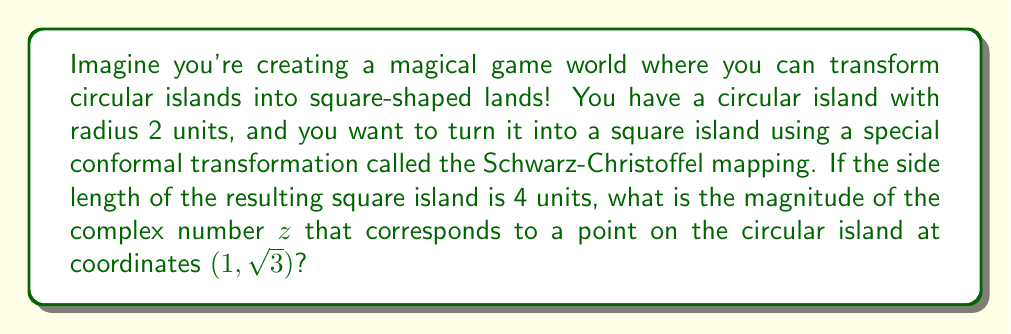Solve this math problem. Let's approach this step-by-step:

1) First, we need to understand that the Schwarz-Christoffel mapping can transform a circle into a square. This is a type of conformal mapping, which means it preserves angles.

2) The point (1, $\sqrt{3}$) on the circular island can be represented as a complex number:

   $z = 1 + i\sqrt{3}$

3) To find the magnitude of this complex number, we use the formula:

   $|z| = \sqrt{a^2 + b^2}$, where $z = a + bi$

4) In this case:

   $|z| = \sqrt{1^2 + (\sqrt{3})^2} = \sqrt{1 + 3} = \sqrt{4} = 2$

5) Now, we've confirmed that this point is indeed on the circle with radius 2.

6) The Schwarz-Christoffel mapping preserves the relative positions of points. This means that a point on the edge of the circle will map to a point on the edge of the square.

7) The circular island has a radius of 2, so its diameter is 4. The square island has a side length of 4. This means the mapping preserves the overall size of the shape.

8) Therefore, the point we're looking at will still be on the edge of the transformed shape, and its distance from the center (i.e., its magnitude) will remain unchanged.

So, the magnitude of the complex number $z$ remains 2, even after the transformation!
Answer: The magnitude of the complex number $z$ is 2. 